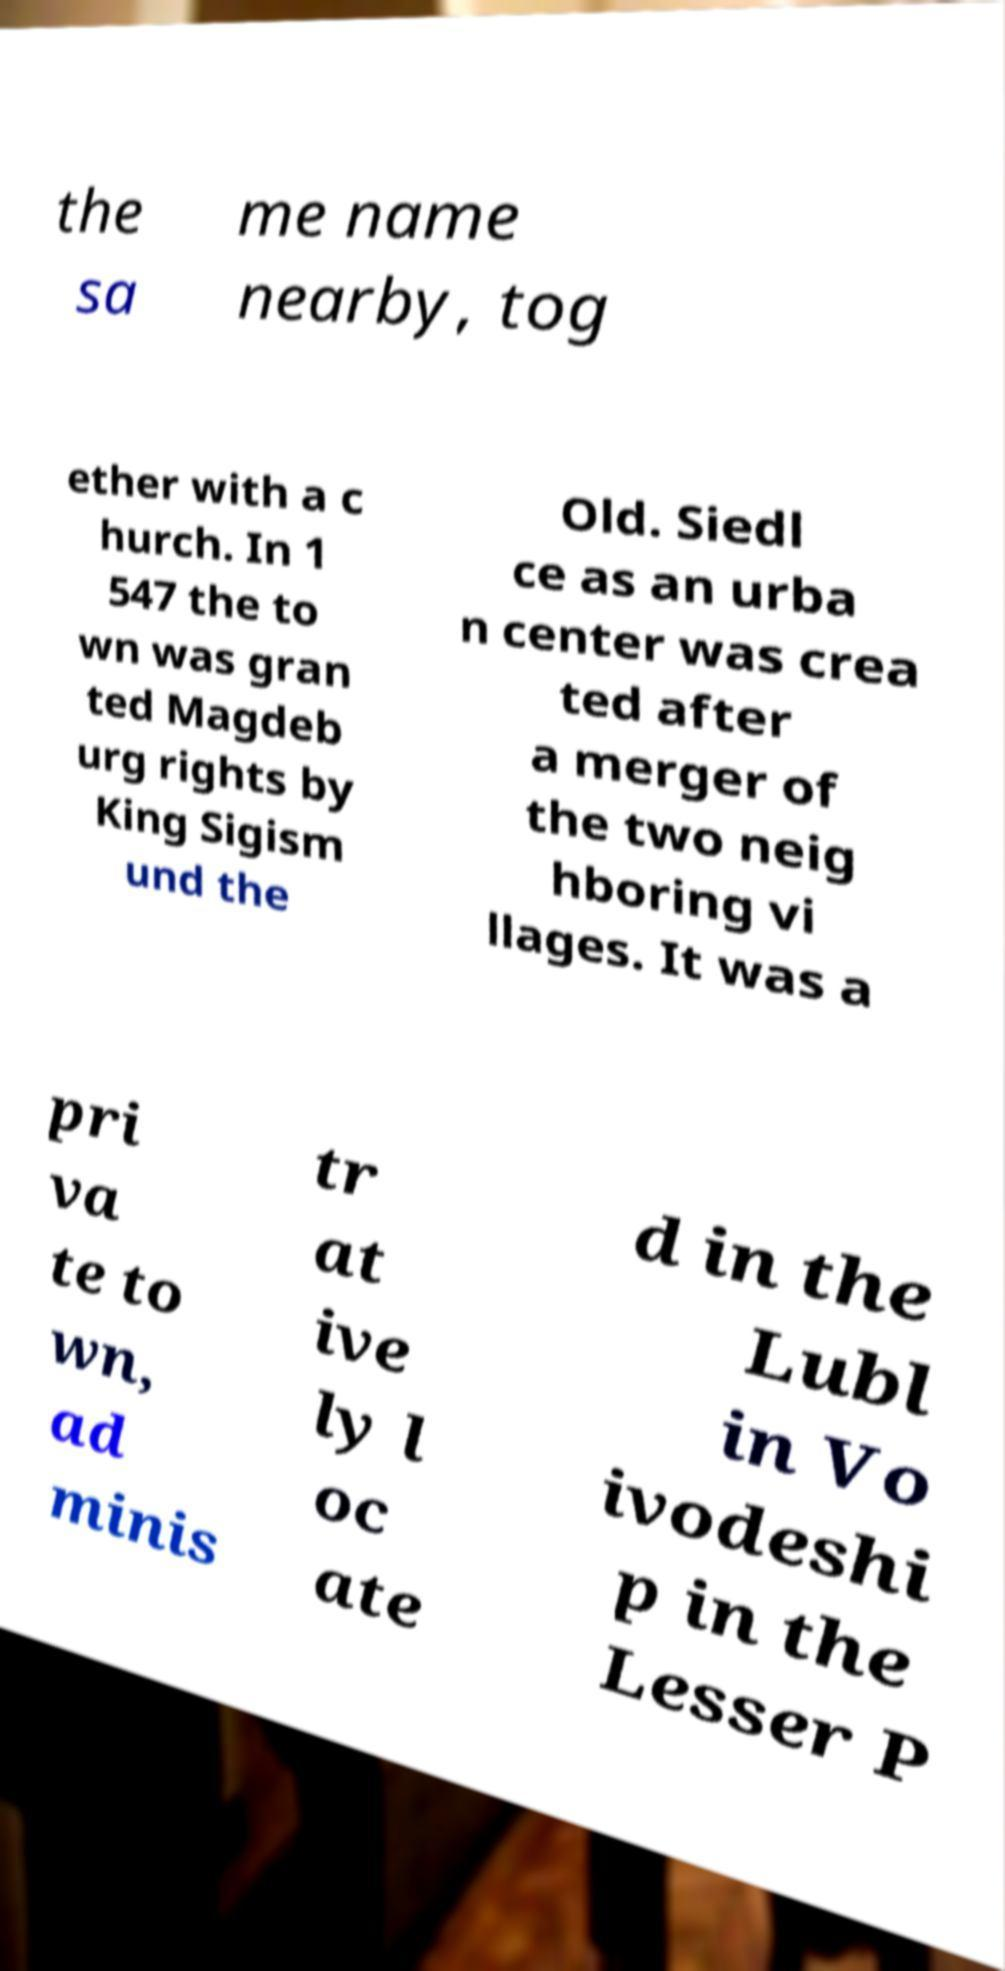Could you assist in decoding the text presented in this image and type it out clearly? the sa me name nearby, tog ether with a c hurch. In 1 547 the to wn was gran ted Magdeb urg rights by King Sigism und the Old. Siedl ce as an urba n center was crea ted after a merger of the two neig hboring vi llages. It was a pri va te to wn, ad minis tr at ive ly l oc ate d in the Lubl in Vo ivodeshi p in the Lesser P 